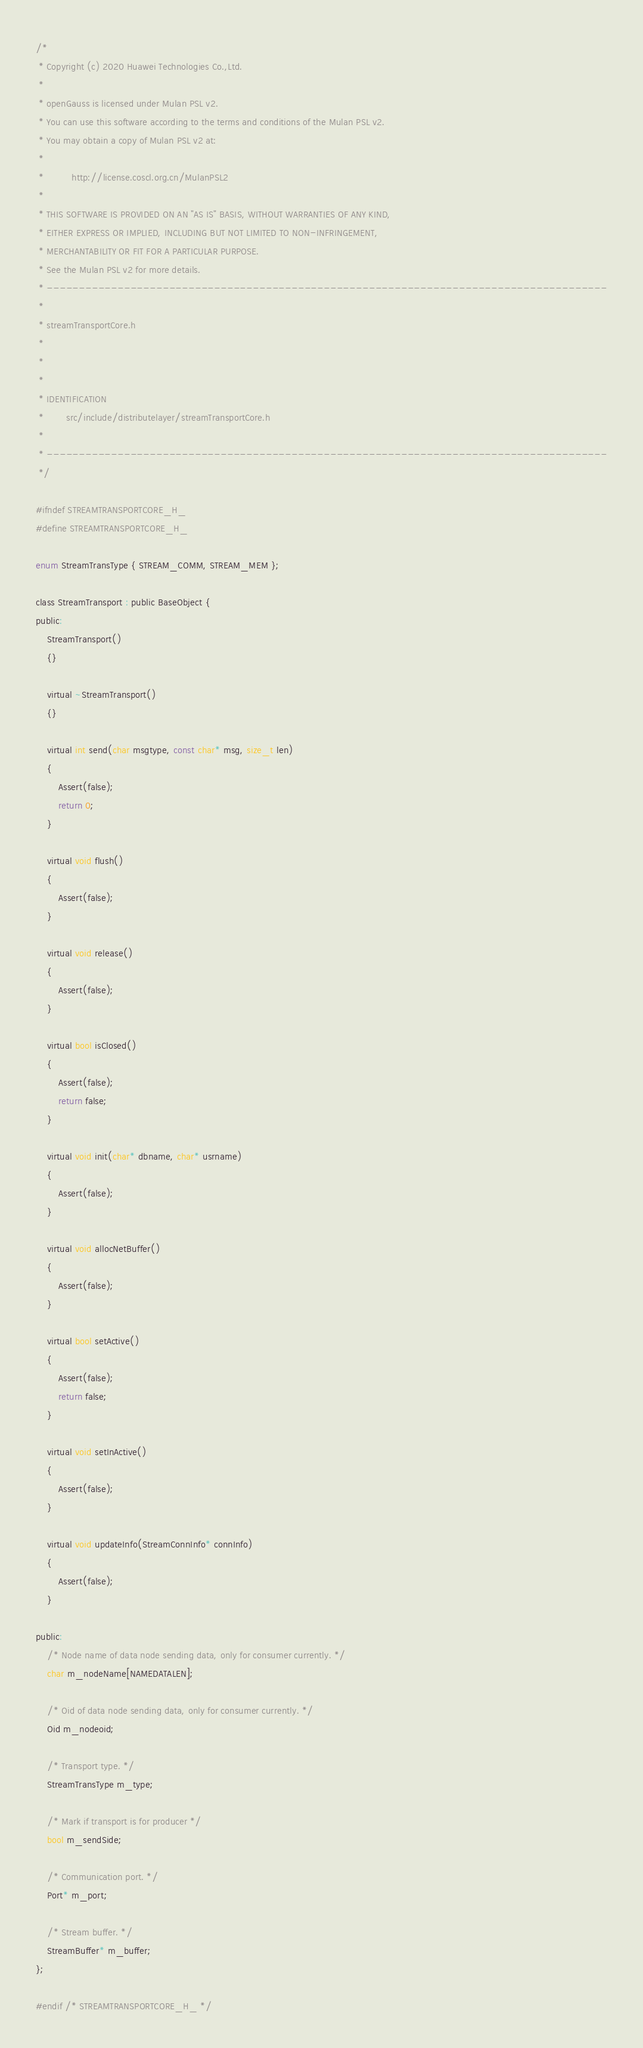Convert code to text. <code><loc_0><loc_0><loc_500><loc_500><_C_>/*
 * Copyright (c) 2020 Huawei Technologies Co.,Ltd.
 *
 * openGauss is licensed under Mulan PSL v2.
 * You can use this software according to the terms and conditions of the Mulan PSL v2.
 * You may obtain a copy of Mulan PSL v2 at:
 *
 *          http://license.coscl.org.cn/MulanPSL2
 *
 * THIS SOFTWARE IS PROVIDED ON AN "AS IS" BASIS, WITHOUT WARRANTIES OF ANY KIND,
 * EITHER EXPRESS OR IMPLIED, INCLUDING BUT NOT LIMITED TO NON-INFRINGEMENT,
 * MERCHANTABILITY OR FIT FOR A PARTICULAR PURPOSE.
 * See the Mulan PSL v2 for more details.
 * ---------------------------------------------------------------------------------------
 * 
 * streamTransportCore.h
 * 
 * 
 * 
 * IDENTIFICATION
 *        src/include/distributelayer/streamTransportCore.h
 *
 * ---------------------------------------------------------------------------------------
 */

#ifndef STREAMTRANSPORTCORE_H_
#define STREAMTRANSPORTCORE_H_

enum StreamTransType { STREAM_COMM, STREAM_MEM };

class StreamTransport : public BaseObject {
public:
    StreamTransport()
    {}

    virtual ~StreamTransport()
    {}

    virtual int send(char msgtype, const char* msg, size_t len)
    {
        Assert(false);
        return 0;
    }

    virtual void flush()
    {
        Assert(false);
    }

    virtual void release()
    {
        Assert(false);
    }

    virtual bool isClosed()
    {
        Assert(false);
        return false;
    }

    virtual void init(char* dbname, char* usrname)
    {
        Assert(false);
    }

    virtual void allocNetBuffer()
    {
        Assert(false);
    }

    virtual bool setActive()
    {
        Assert(false);
        return false;
    }

    virtual void setInActive()
    {
        Assert(false);
    }

    virtual void updateInfo(StreamConnInfo* connInfo)
    {
        Assert(false);
    }

public:
    /* Node name of data node sending data, only for consumer currently. */
    char m_nodeName[NAMEDATALEN];

    /* Oid of data node sending data, only for consumer currently. */
    Oid m_nodeoid;

    /* Transport type. */
    StreamTransType m_type;

    /* Mark if transport is for producer */
    bool m_sendSide;

    /* Communication port. */
    Port* m_port;

    /* Stream buffer. */
    StreamBuffer* m_buffer;
};

#endif /* STREAMTRANSPORTCORE_H_ */
</code> 